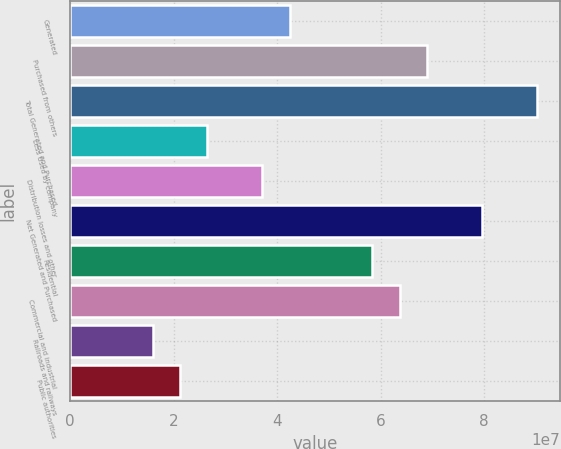Convert chart. <chart><loc_0><loc_0><loc_500><loc_500><bar_chart><fcel>Generated<fcel>Purchased from others<fcel>Total Generated and Purchased<fcel>Less Used by company<fcel>Distribution losses and other<fcel>Net Generated and Purchased<fcel>Residential<fcel>Commercial and industrial<fcel>Railroads and railways<fcel>Public authorities<nl><fcel>4.24399e+07<fcel>6.89648e+07<fcel>9.01847e+07<fcel>2.65249e+07<fcel>3.71349e+07<fcel>7.95748e+07<fcel>5.83548e+07<fcel>6.36598e+07<fcel>1.5915e+07<fcel>2.122e+07<nl></chart> 